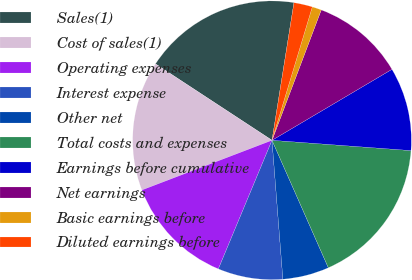<chart> <loc_0><loc_0><loc_500><loc_500><pie_chart><fcel>Sales(1)<fcel>Cost of sales(1)<fcel>Operating expenses<fcel>Interest expense<fcel>Other net<fcel>Total costs and expenses<fcel>Earnings before cumulative<fcel>Net earnings<fcel>Basic earnings before<fcel>Diluted earnings before<nl><fcel>18.28%<fcel>15.05%<fcel>12.9%<fcel>7.53%<fcel>5.38%<fcel>17.2%<fcel>9.68%<fcel>10.75%<fcel>1.08%<fcel>2.15%<nl></chart> 